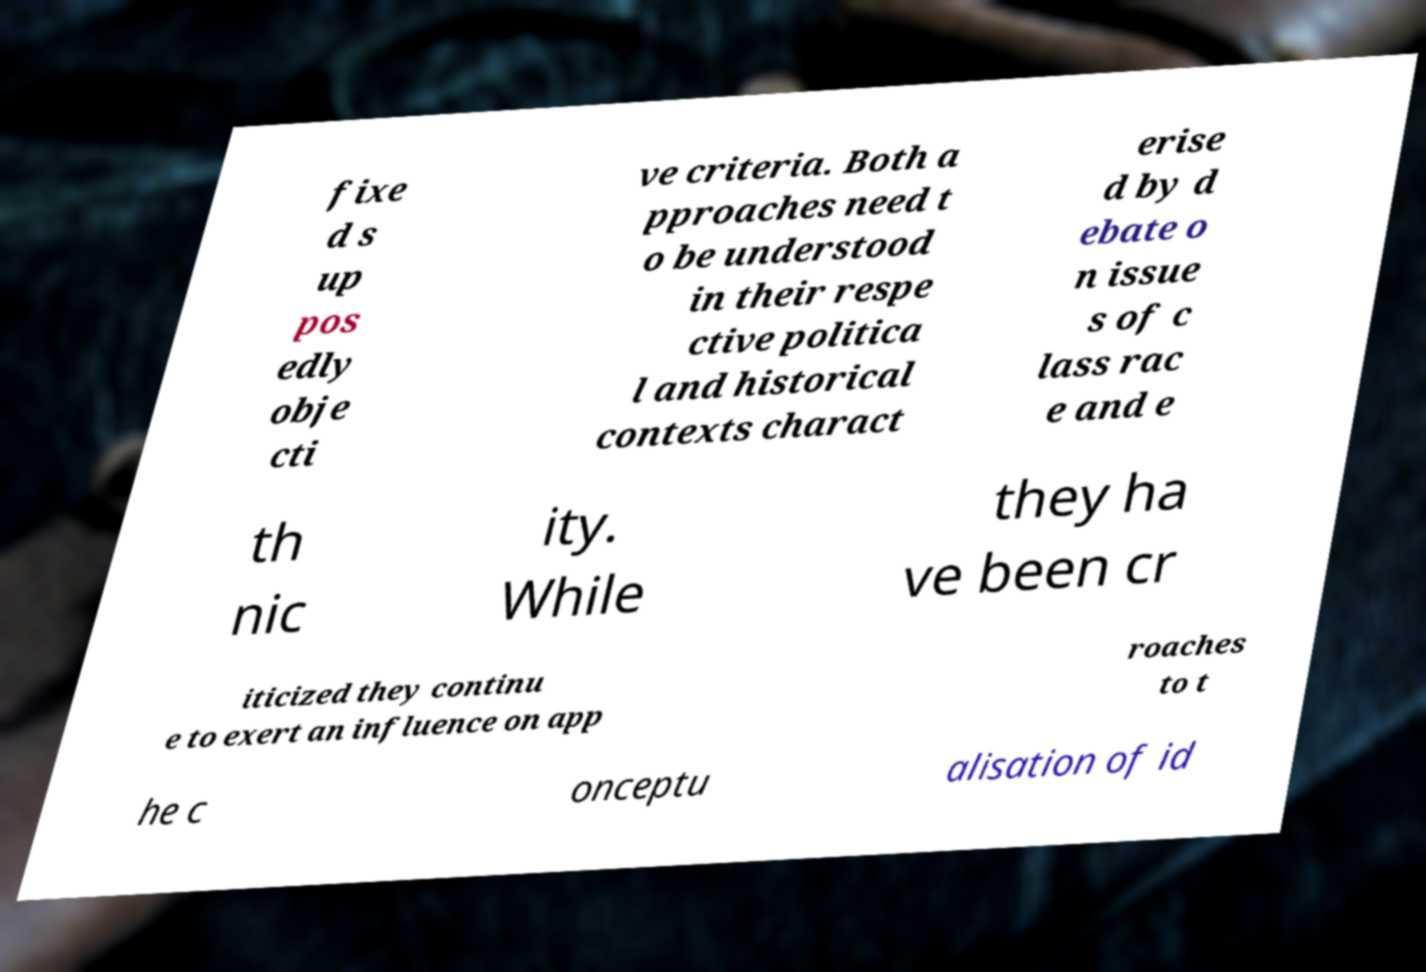There's text embedded in this image that I need extracted. Can you transcribe it verbatim? fixe d s up pos edly obje cti ve criteria. Both a pproaches need t o be understood in their respe ctive politica l and historical contexts charact erise d by d ebate o n issue s of c lass rac e and e th nic ity. While they ha ve been cr iticized they continu e to exert an influence on app roaches to t he c onceptu alisation of id 